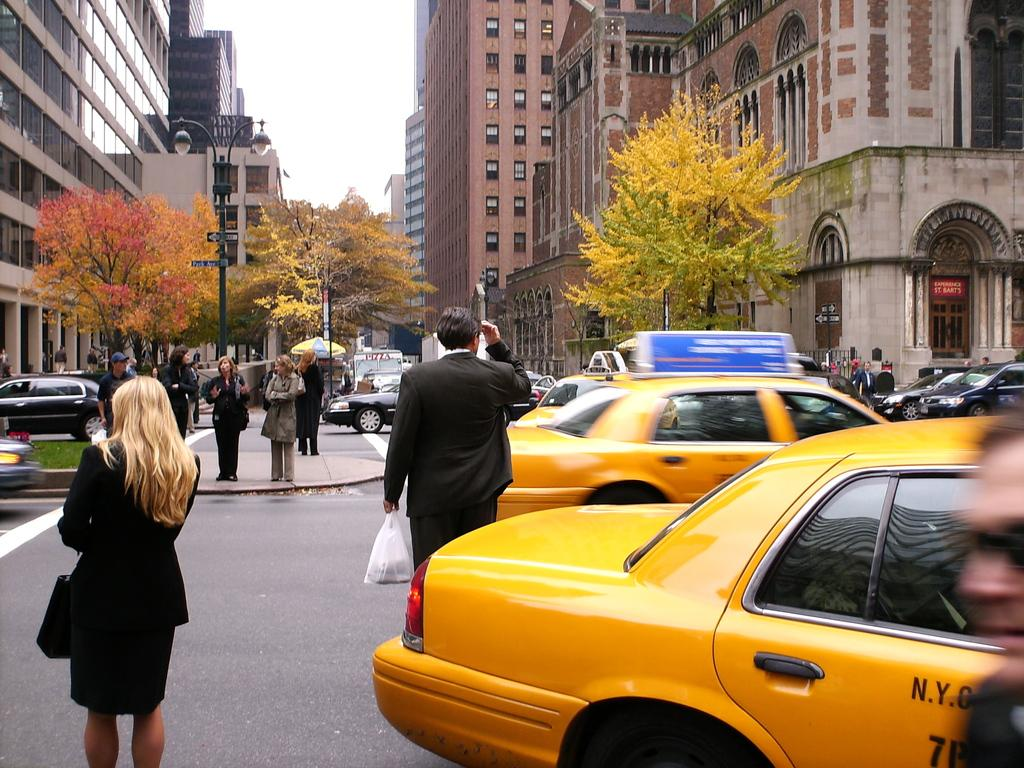<image>
Relay a brief, clear account of the picture shown. Two yellow taxi cab with the letters N.Y. written on the side. 